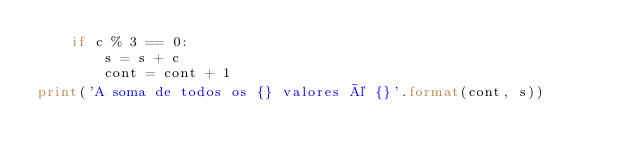Convert code to text. <code><loc_0><loc_0><loc_500><loc_500><_Python_>    if c % 3 == 0:
        s = s + c
        cont = cont + 1
print('A soma de todos os {} valores é {}'.format(cont, s))
</code> 